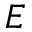<formula> <loc_0><loc_0><loc_500><loc_500>E</formula> 